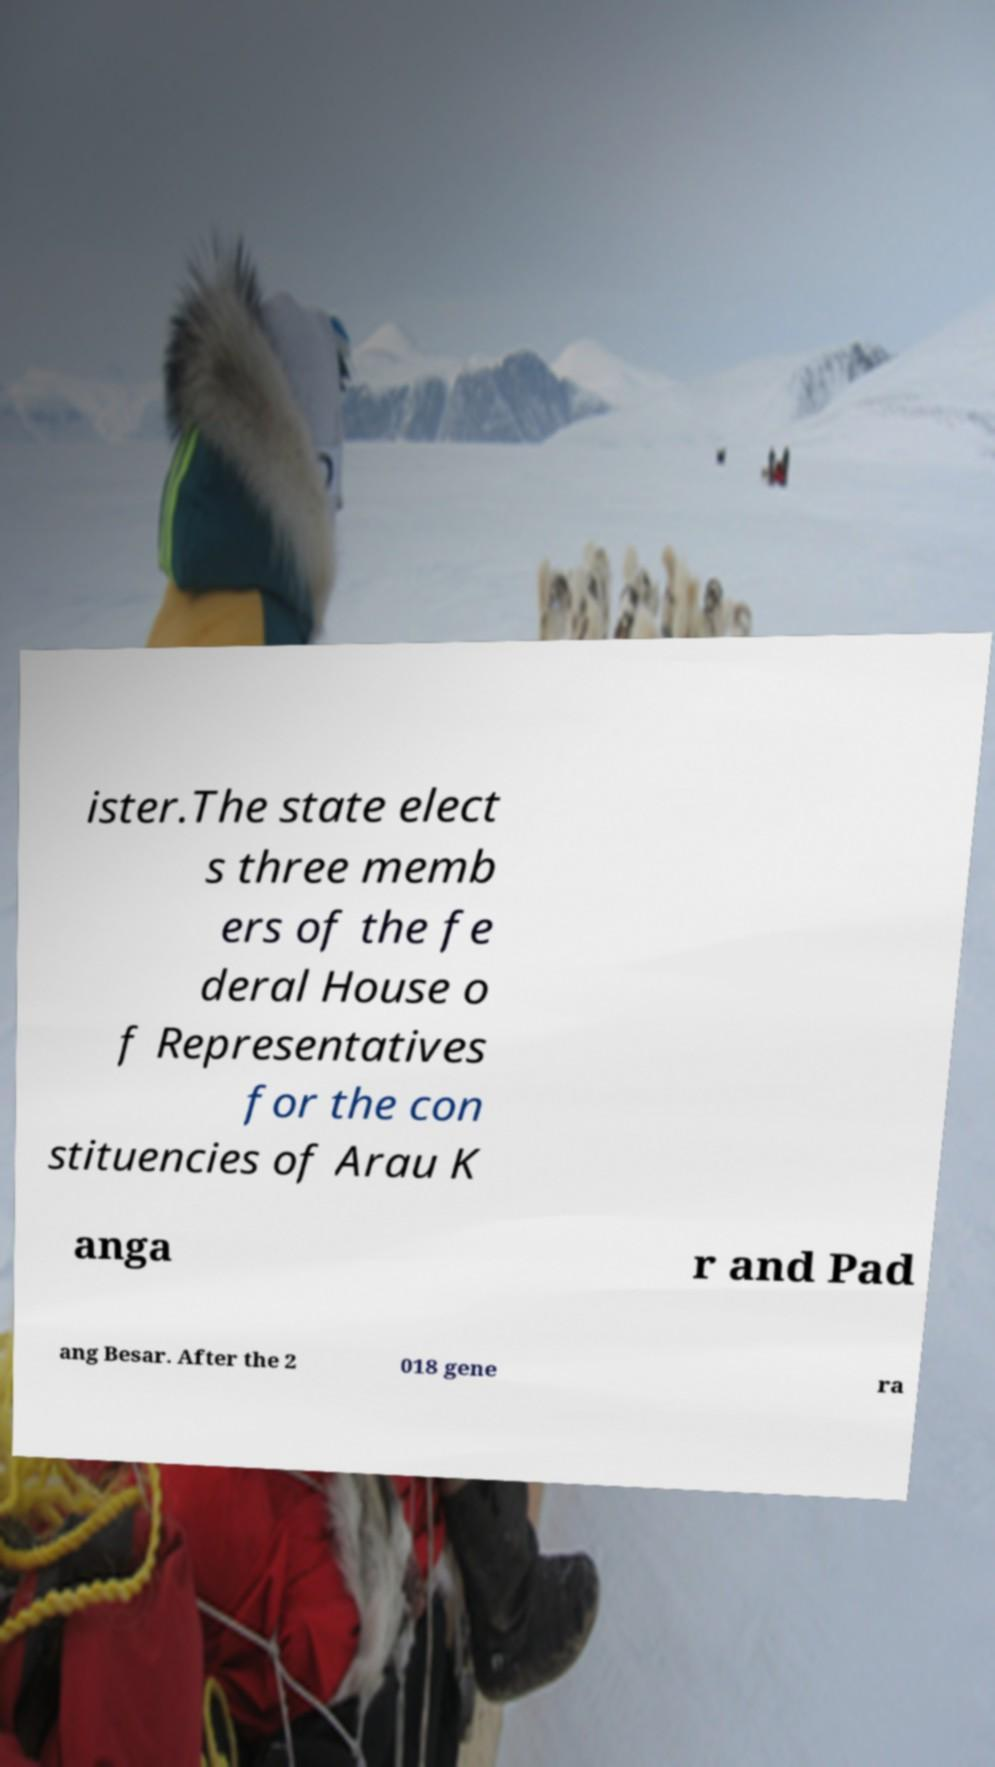Can you accurately transcribe the text from the provided image for me? ister.The state elect s three memb ers of the fe deral House o f Representatives for the con stituencies of Arau K anga r and Pad ang Besar. After the 2 018 gene ra 